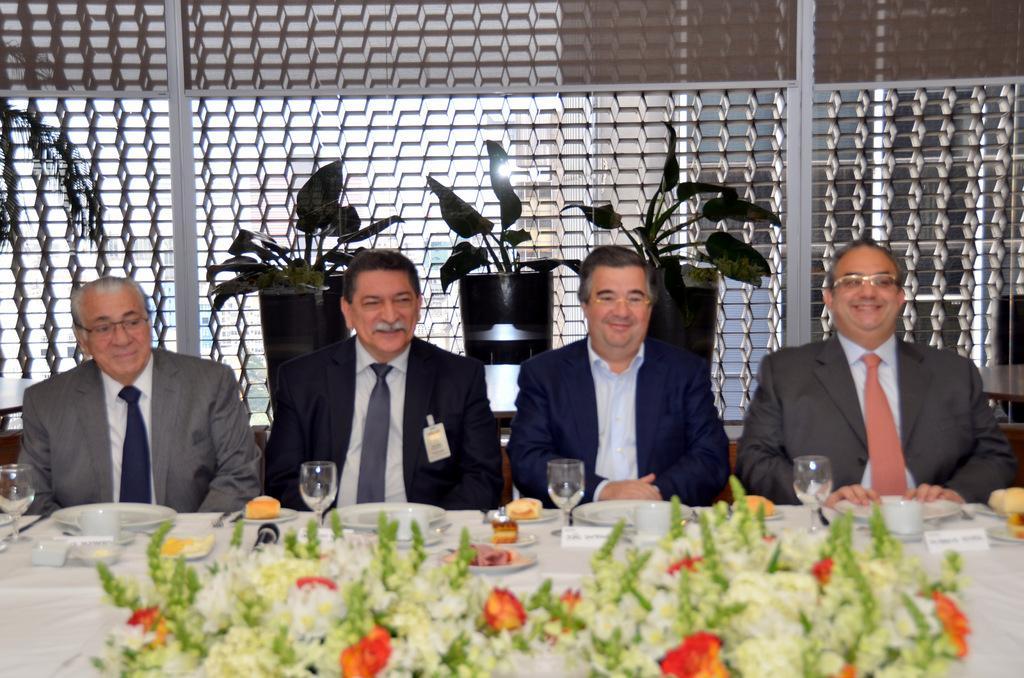Can you describe this image briefly? In the center of the image there are four people sitting. In front of them there is a table. On which there are glasses,plates and many other objects. In the bottom of the image there is a flower vase. In the background of the image there are plants. 